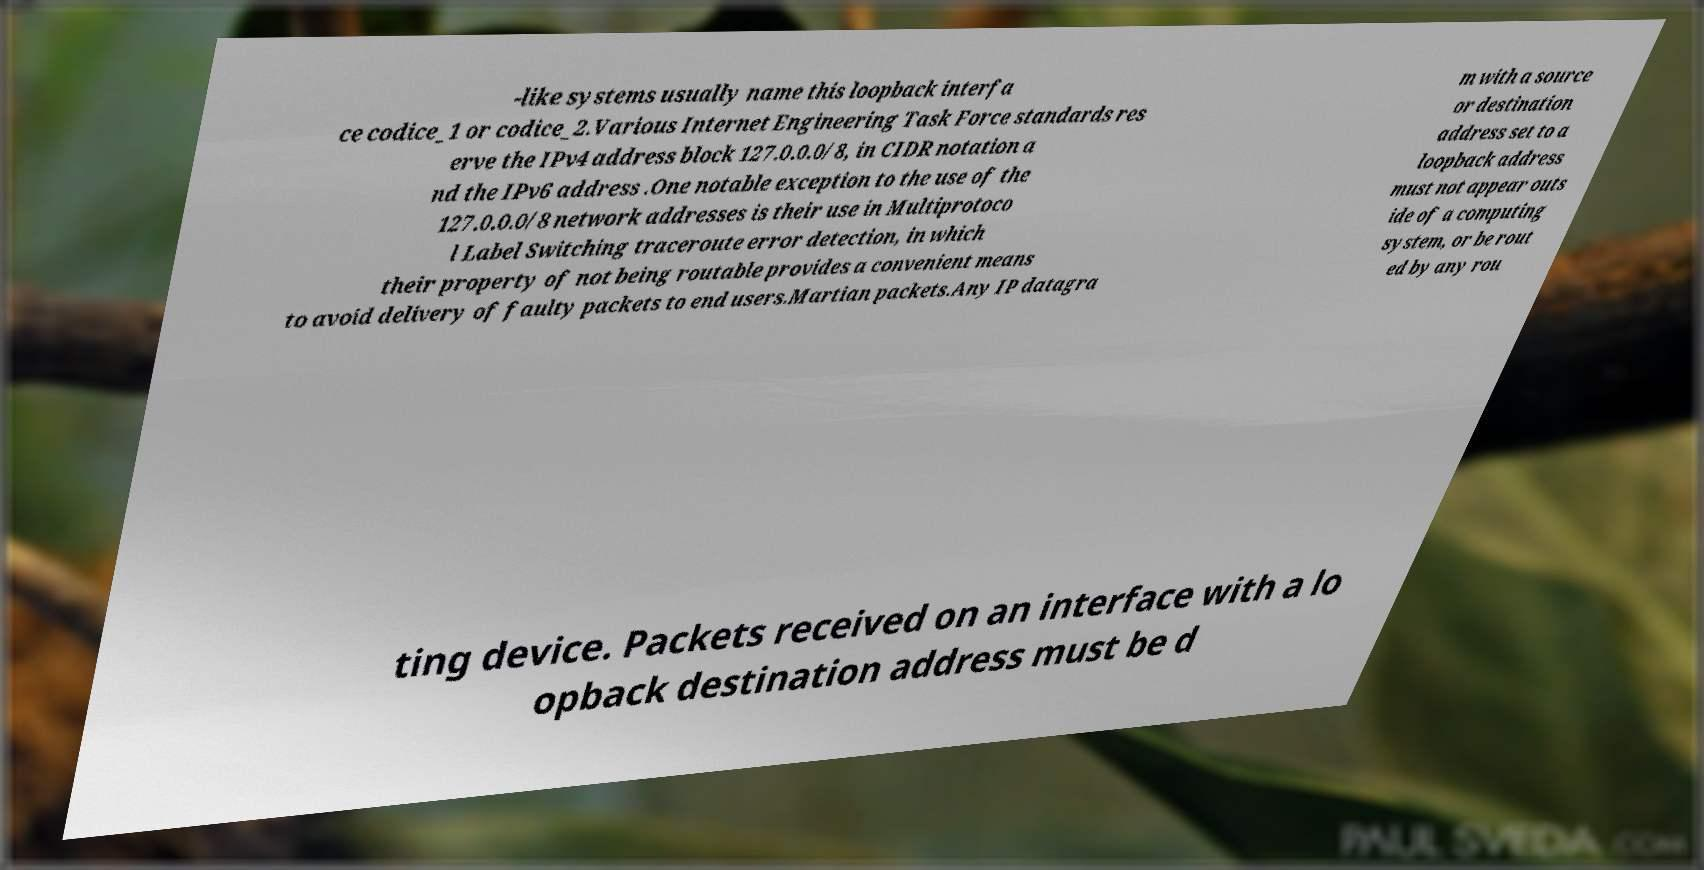Can you read and provide the text displayed in the image?This photo seems to have some interesting text. Can you extract and type it out for me? -like systems usually name this loopback interfa ce codice_1 or codice_2.Various Internet Engineering Task Force standards res erve the IPv4 address block 127.0.0.0/8, in CIDR notation a nd the IPv6 address .One notable exception to the use of the 127.0.0.0/8 network addresses is their use in Multiprotoco l Label Switching traceroute error detection, in which their property of not being routable provides a convenient means to avoid delivery of faulty packets to end users.Martian packets.Any IP datagra m with a source or destination address set to a loopback address must not appear outs ide of a computing system, or be rout ed by any rou ting device. Packets received on an interface with a lo opback destination address must be d 